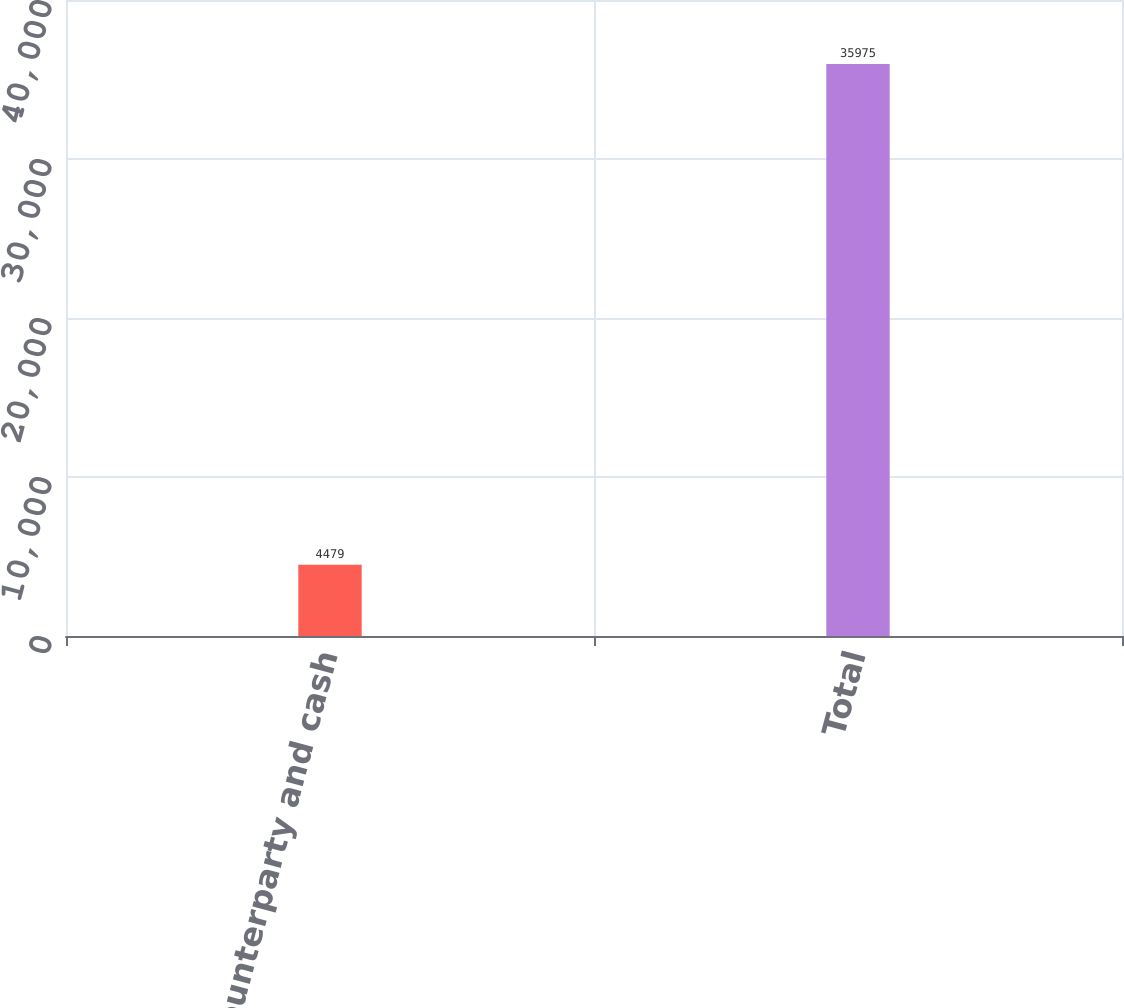Convert chart to OTSL. <chart><loc_0><loc_0><loc_500><loc_500><bar_chart><fcel>Counterparty and cash<fcel>Total<nl><fcel>4479<fcel>35975<nl></chart> 